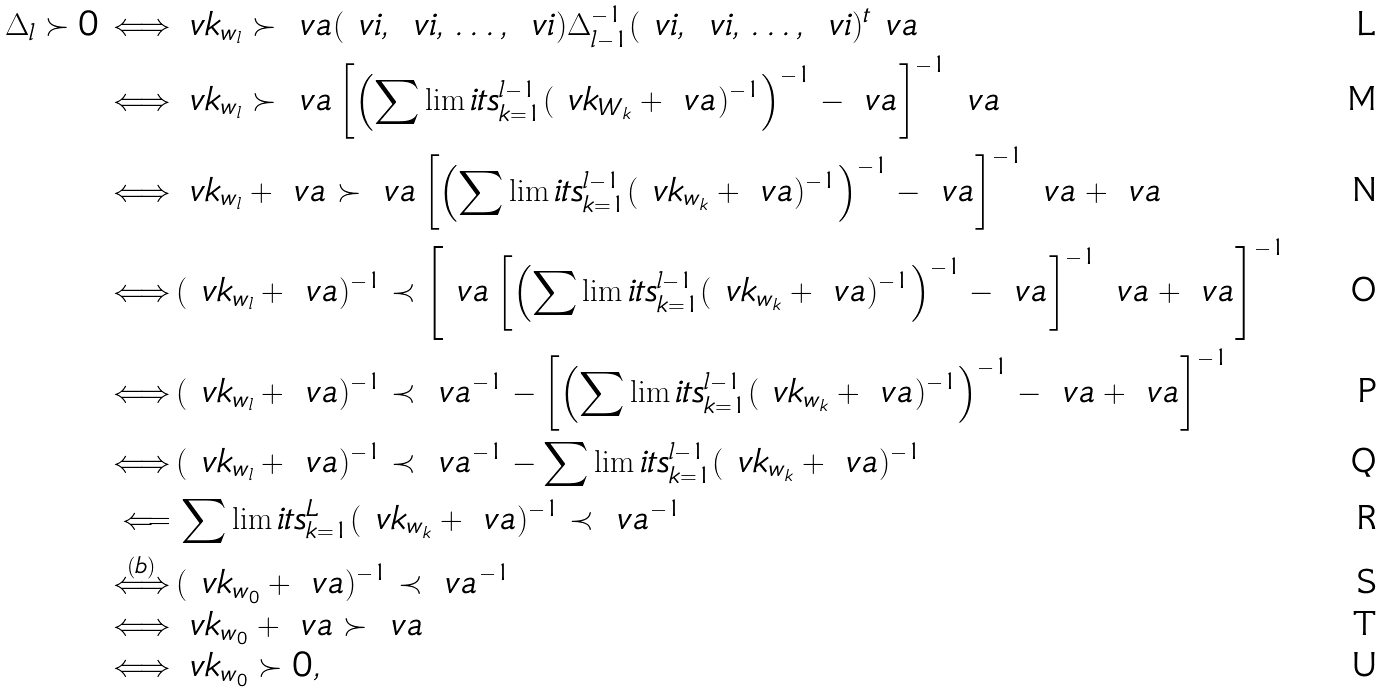<formula> <loc_0><loc_0><loc_500><loc_500>\Delta _ { l } \succ 0 \, \Longleftrightarrow \, & \ v k _ { w _ { l } } \succ \ v a ( \ v i , \, \ v i , \, \dots , \, \ v i ) \Delta _ { l - 1 } ^ { - 1 } ( \ v i , \, \ v i , \, \dots , \, \ v i ) ^ { t } \ v a \\ \, \Longleftrightarrow \, & \ v k _ { w _ { l } } \succ \ v a \left [ \left ( \sum \lim i t s _ { k = 1 } ^ { l - 1 } ( \ v k _ { W _ { k } } + \ v a ) ^ { - 1 } \right ) ^ { - 1 } - \ v a \right ] ^ { - 1 } \ v a \\ \, \Longleftrightarrow \, & \ v k _ { w _ { l } } + \ v a \succ \ v a \left [ \left ( \sum \lim i t s _ { k = 1 } ^ { l - 1 } ( \ v k _ { w _ { k } } + \ v a ) ^ { - 1 } \right ) ^ { - 1 } - \ v a \right ] ^ { - 1 } \ v a + \ v a \\ \, \Longleftrightarrow \, & ( \ v k _ { w _ { l } } + \ v a ) ^ { - 1 } \prec \left [ \ v a \left [ \left ( \sum \lim i t s _ { k = 1 } ^ { l - 1 } ( \ v k _ { w _ { k } } + \ v a ) ^ { - 1 } \right ) ^ { - 1 } - \ v a \right ] ^ { - 1 } \ v a + \ v a \right ] ^ { - 1 } \\ \, \Longleftrightarrow \, & ( \ v k _ { w _ { l } } + \ v a ) ^ { - 1 } \prec \ v a ^ { - 1 } - \left [ \left ( \sum \lim i t s _ { k = 1 } ^ { l - 1 } ( \ v k _ { w _ { k } } + \ v a ) ^ { - 1 } \right ) ^ { - 1 } - \ v a + \ v a \right ] ^ { - 1 } \\ \, \Longleftrightarrow \, & ( \ v k _ { w _ { l } } + \ v a ) ^ { - 1 } \prec \ v a ^ { - 1 } - \sum \lim i t s _ { k = 1 } ^ { l - 1 } ( \ v k _ { w _ { k } } + \ v a ) ^ { - 1 } \\ \, { \Longleftarrow } \, & \sum \lim i t s _ { k = 1 } ^ { L } ( \ v k _ { w _ { k } } + \ v a ) ^ { - 1 } \prec \ v a ^ { - 1 } \\ \, \overset { ( b ) } { \Longleftrightarrow } \, & ( \ v k _ { w _ { 0 } } + \ v a ) ^ { - 1 } \prec \ v a ^ { - 1 } \\ \, \Longleftrightarrow \, & \ v k _ { w _ { 0 } } + \ v a \succ \ v a \\ \, \Longleftrightarrow \, & \ v k _ { w _ { 0 } } \succ 0 ,</formula> 